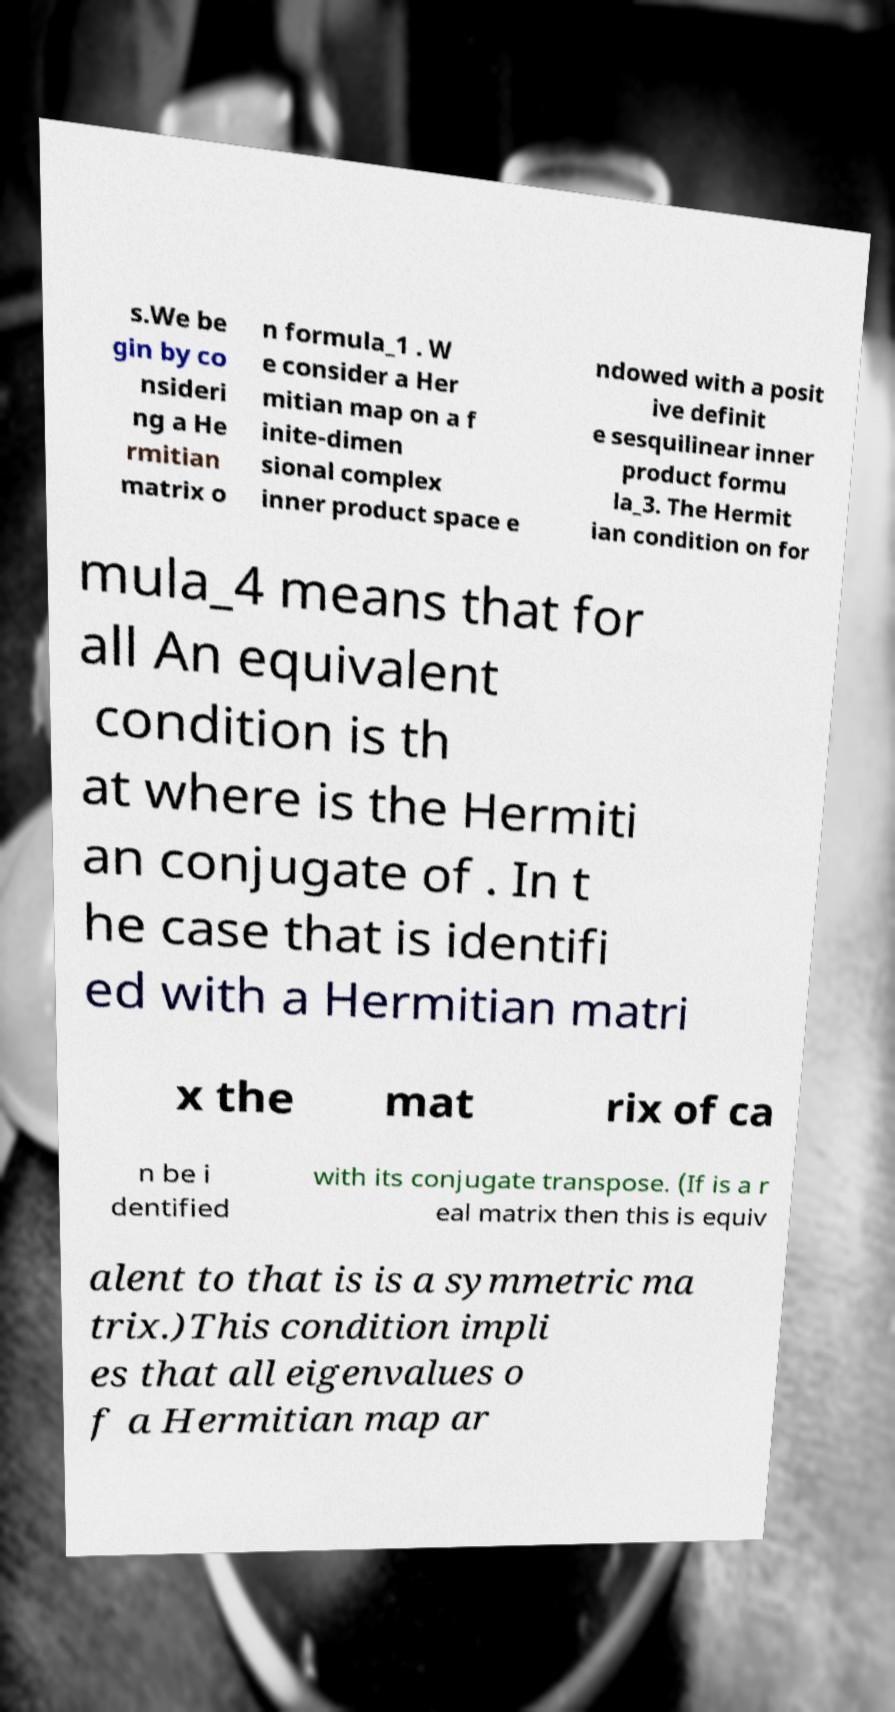I need the written content from this picture converted into text. Can you do that? s.We be gin by co nsideri ng a He rmitian matrix o n formula_1 . W e consider a Her mitian map on a f inite-dimen sional complex inner product space e ndowed with a posit ive definit e sesquilinear inner product formu la_3. The Hermit ian condition on for mula_4 means that for all An equivalent condition is th at where is the Hermiti an conjugate of . In t he case that is identifi ed with a Hermitian matri x the mat rix of ca n be i dentified with its conjugate transpose. (If is a r eal matrix then this is equiv alent to that is is a symmetric ma trix.)This condition impli es that all eigenvalues o f a Hermitian map ar 